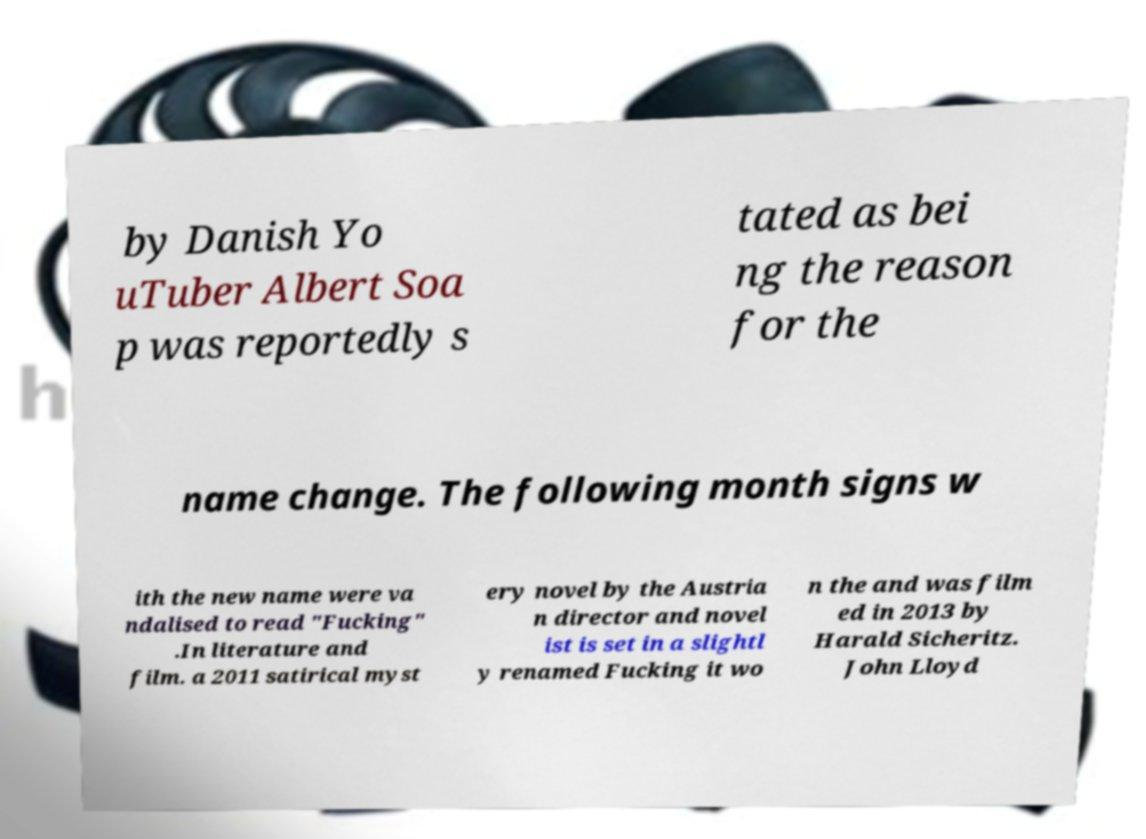Can you read and provide the text displayed in the image?This photo seems to have some interesting text. Can you extract and type it out for me? by Danish Yo uTuber Albert Soa p was reportedly s tated as bei ng the reason for the name change. The following month signs w ith the new name were va ndalised to read "Fucking" .In literature and film. a 2011 satirical myst ery novel by the Austria n director and novel ist is set in a slightl y renamed Fucking it wo n the and was film ed in 2013 by Harald Sicheritz. John Lloyd 